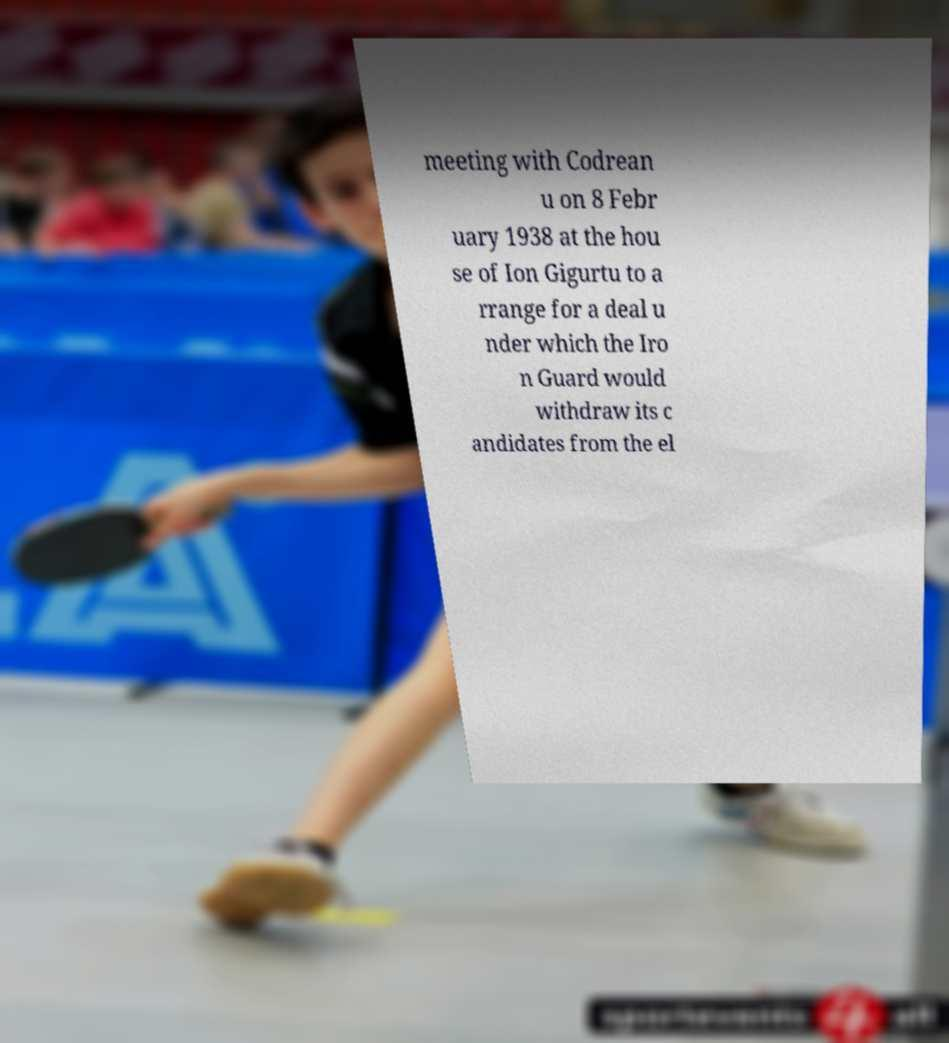There's text embedded in this image that I need extracted. Can you transcribe it verbatim? meeting with Codrean u on 8 Febr uary 1938 at the hou se of Ion Gigurtu to a rrange for a deal u nder which the Iro n Guard would withdraw its c andidates from the el 